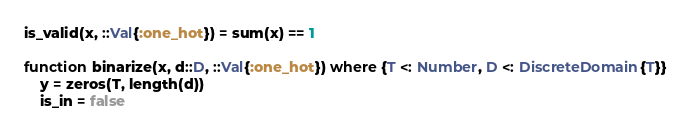Convert code to text. <code><loc_0><loc_0><loc_500><loc_500><_Julia_>is_valid(x, ::Val{:one_hot}) = sum(x) == 1

function binarize(x, d::D, ::Val{:one_hot}) where {T <: Number, D <: DiscreteDomain{T}}
    y = zeros(T, length(d))
    is_in = false</code> 